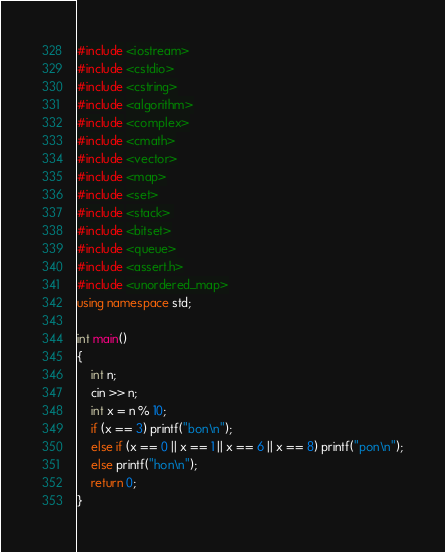Convert code to text. <code><loc_0><loc_0><loc_500><loc_500><_C++_>#include <iostream>
#include <cstdio>
#include <cstring>
#include <algorithm>
#include <complex>
#include <cmath>
#include <vector>
#include <map>
#include <set>
#include <stack> 
#include <bitset>
#include <queue>
#include <assert.h>
#include <unordered_map>
using namespace std;

int main()
{
	int n;
	cin >> n;
	int x = n % 10;
	if (x == 3) printf("bon\n");
	else if (x == 0 || x == 1 || x == 6 || x == 8) printf("pon\n");
	else printf("hon\n");
	return 0;
}
</code> 